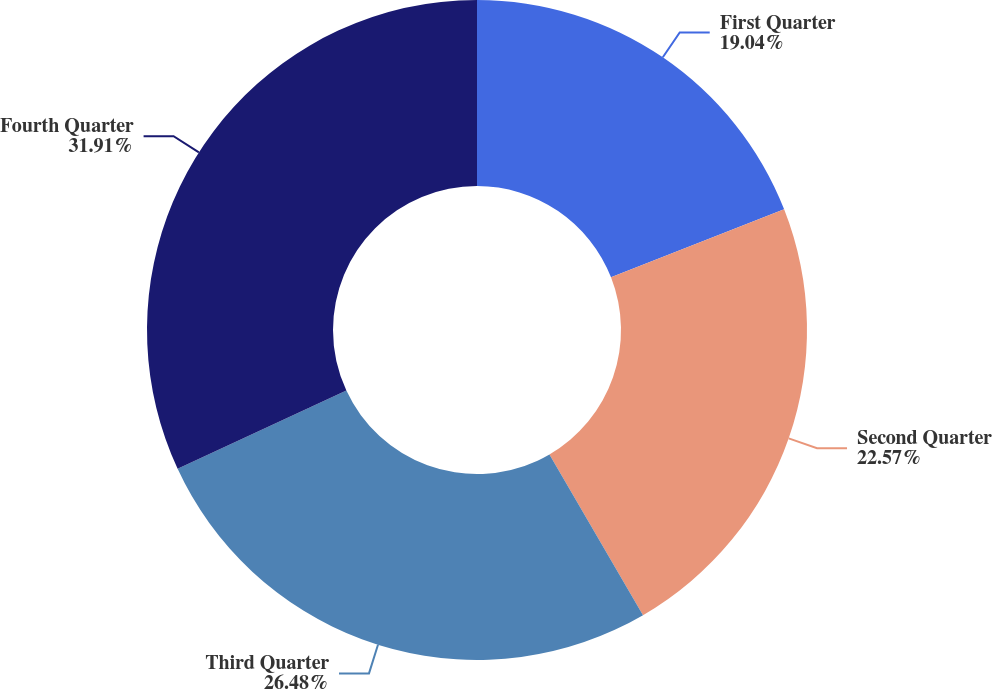Convert chart. <chart><loc_0><loc_0><loc_500><loc_500><pie_chart><fcel>First Quarter<fcel>Second Quarter<fcel>Third Quarter<fcel>Fourth Quarter<nl><fcel>19.04%<fcel>22.57%<fcel>26.48%<fcel>31.91%<nl></chart> 